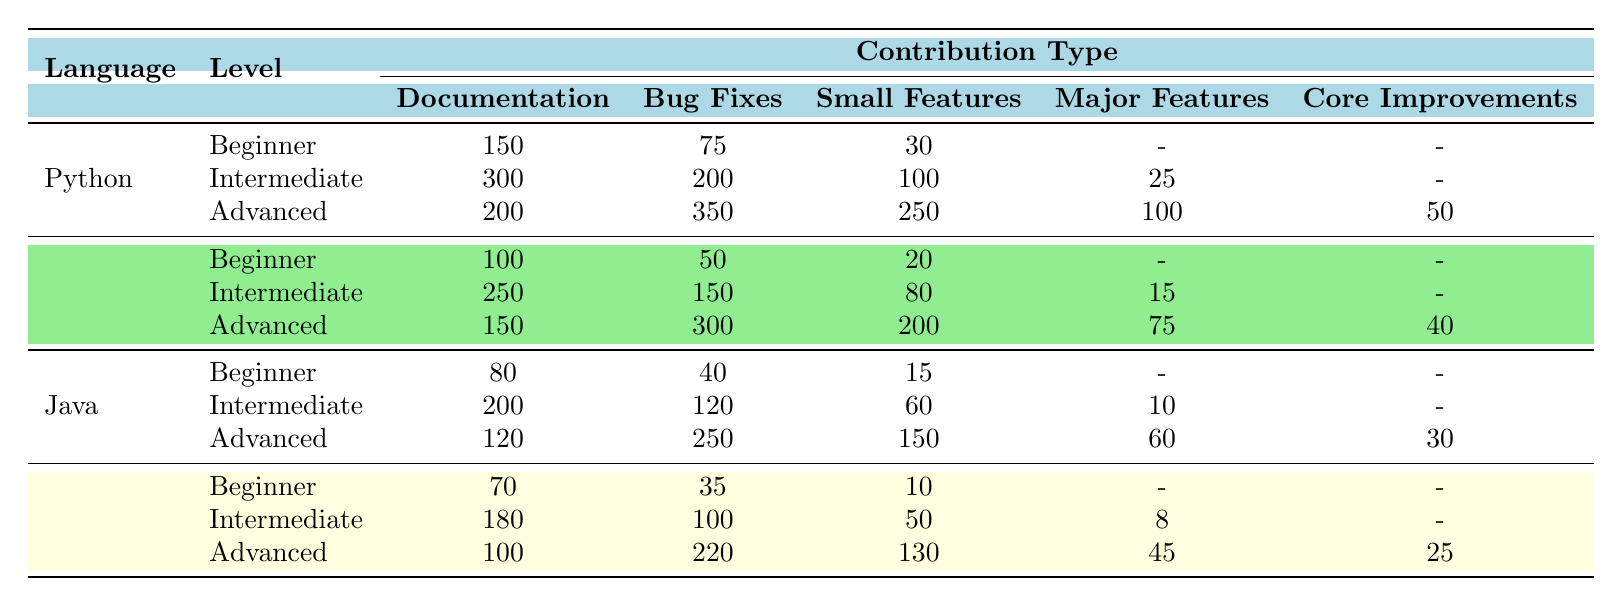What is the number of documentation contributions by Advanced Python contributors? According to the table, the Advanced Python contributors made 200 documentation contributions.
Answer: 200 How many bug fixes did Beginner Java contributors make? The table shows that Beginner Java contributors made 40 bug fixes.
Answer: 40 What is the total number of small features contributed by Advanced contributors across all languages? From the table, Advanced contributions include 250 (Python) + 200 (JavaScript) + 150 (Java) + 130 (Ruby) = 730 small features.
Answer: 730 Which programming language has the highest number of bug fixes for Advanced contributors? Looking at the bug fixes from Advanced contributors, Python has 350, JavaScript has 300, Java has 250, and Ruby has 220. The highest is Python with 350 bug fixes.
Answer: Python What is the average number of major features contributed by Intermediate contributors across all programming languages? The Intermediate contributors provided major features as follows: 25 (Python) + 15 (JavaScript) + 10 (Java) + 8 (Ruby) = 58. There are 4 languages, so the average is 58/4 = 14.5.
Answer: 14.5 Did any Beginner contributors contribute to Core Improvements? The table shows no contributions to Core Improvements from any Beginner contributors. Therefore, the answer is no.
Answer: No How many total contributions from Intermediate JavaScript contributors are there? Adding up the contributions: 250 (Documentation) + 150 (Bug Fixes) + 80 (Small Features) + 15 (Major Features) = 495 total contributions.
Answer: 495 Which language had the least number of documented contributions from Beginner contributors? The documented contributions from Beginner contributors are: Python (150), JavaScript (100), Java (80), and Ruby (70). Ruby had the least with 70 documented contributions.
Answer: Ruby How does the total number of Beginner Bug Fix contributions compare between Python and Ruby? Python has 75 Beginner Bug Fix contributions, while Ruby has 35. Therefore, Python has more contributions than Ruby.
Answer: Python has more What is the total number of contributions (all types) for Advanced contributors in Java? The total contributions from Advanced Java contributors are 120 (Documentation) + 250 (Bug Fixes) + 150 (Small Features) + 60 (Major Features) + 30 (Core Improvements) = 610.
Answer: 610 